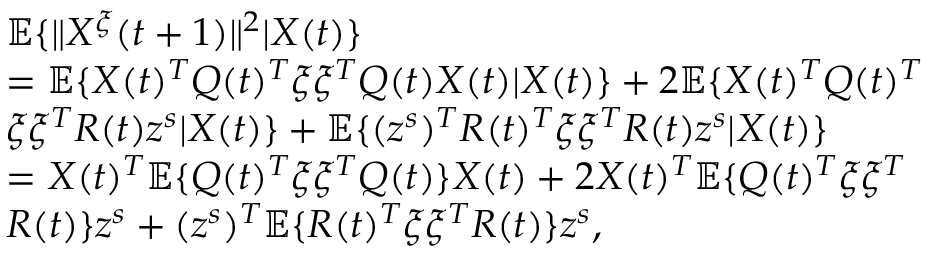Convert formula to latex. <formula><loc_0><loc_0><loc_500><loc_500>\begin{array} { r l } & { \mathbb { E } \{ \| X ^ { \xi } ( t + 1 ) \| ^ { 2 } | X ( t ) \} } \\ & { = \mathbb { E } \{ X ( t ) ^ { T } Q ( t ) ^ { T } \xi \xi ^ { T } Q ( t ) X ( t ) | X ( t ) \} + 2 \mathbb { E } \{ X ( t ) ^ { T } Q ( t ) ^ { T } } \\ & { \xi \xi ^ { T } R ( t ) z ^ { s } | X ( t ) \} + \mathbb { E } \{ ( z ^ { s } ) ^ { T } R ( t ) ^ { T } \xi \xi ^ { T } R ( t ) z ^ { s } | X ( t ) \} } \\ & { = X ( t ) ^ { T } \mathbb { E } \{ Q ( t ) ^ { T } \xi \xi ^ { T } Q ( t ) \} X ( t ) + 2 X ( t ) ^ { T } \mathbb { E } \{ Q ( t ) ^ { T } \xi \xi ^ { T } } \\ & { R ( t ) \} z ^ { s } + ( z ^ { s } ) ^ { T } \mathbb { E } \{ R ( t ) ^ { T } \xi \xi ^ { T } R ( t ) \} z ^ { s } , } \end{array}</formula> 